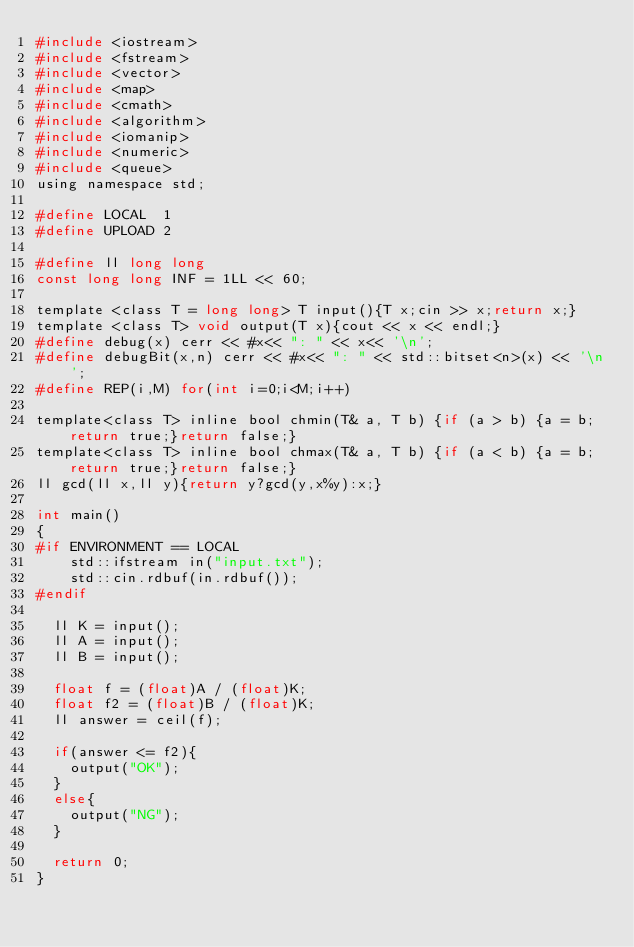Convert code to text. <code><loc_0><loc_0><loc_500><loc_500><_C_>#include <iostream>
#include <fstream>
#include <vector>
#include <map>
#include <cmath>
#include <algorithm>
#include <iomanip>
#include <numeric>
#include <queue>
using namespace std;
 
#define LOCAL  1
#define UPLOAD 2
 
#define ll long long
const long long INF = 1LL << 60;
 
template <class T = long long> T input(){T x;cin >> x;return x;}
template <class T> void output(T x){cout << x << endl;}
#define debug(x) cerr << #x<< ": " << x<< '\n';
#define debugBit(x,n) cerr << #x<< ": " << std::bitset<n>(x) << '\n';
#define REP(i,M) for(int i=0;i<M;i++)
 
template<class T> inline bool chmin(T& a, T b) {if (a > b) {a = b;return true;}return false;}
template<class T> inline bool chmax(T& a, T b) {if (a < b) {a = b;return true;}return false;}
ll gcd(ll x,ll y){return y?gcd(y,x%y):x;}
 
int main()
{
#if ENVIRONMENT == LOCAL
    std::ifstream in("input.txt");
    std::cin.rdbuf(in.rdbuf());
#endif
  
  ll K = input();
  ll A = input();
  ll B = input();

  float f = (float)A / (float)K;
  float f2 = (float)B / (float)K;
  ll answer = ceil(f);

  if(answer <= f2){
    output("OK");
  }
  else{
    output("NG");
  }
  
  return 0;
}</code> 